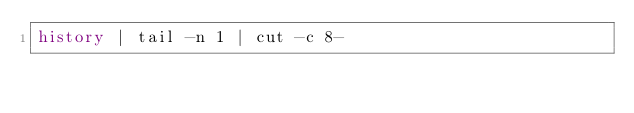<code> <loc_0><loc_0><loc_500><loc_500><_Bash_>history | tail -n 1 | cut -c 8-
</code> 